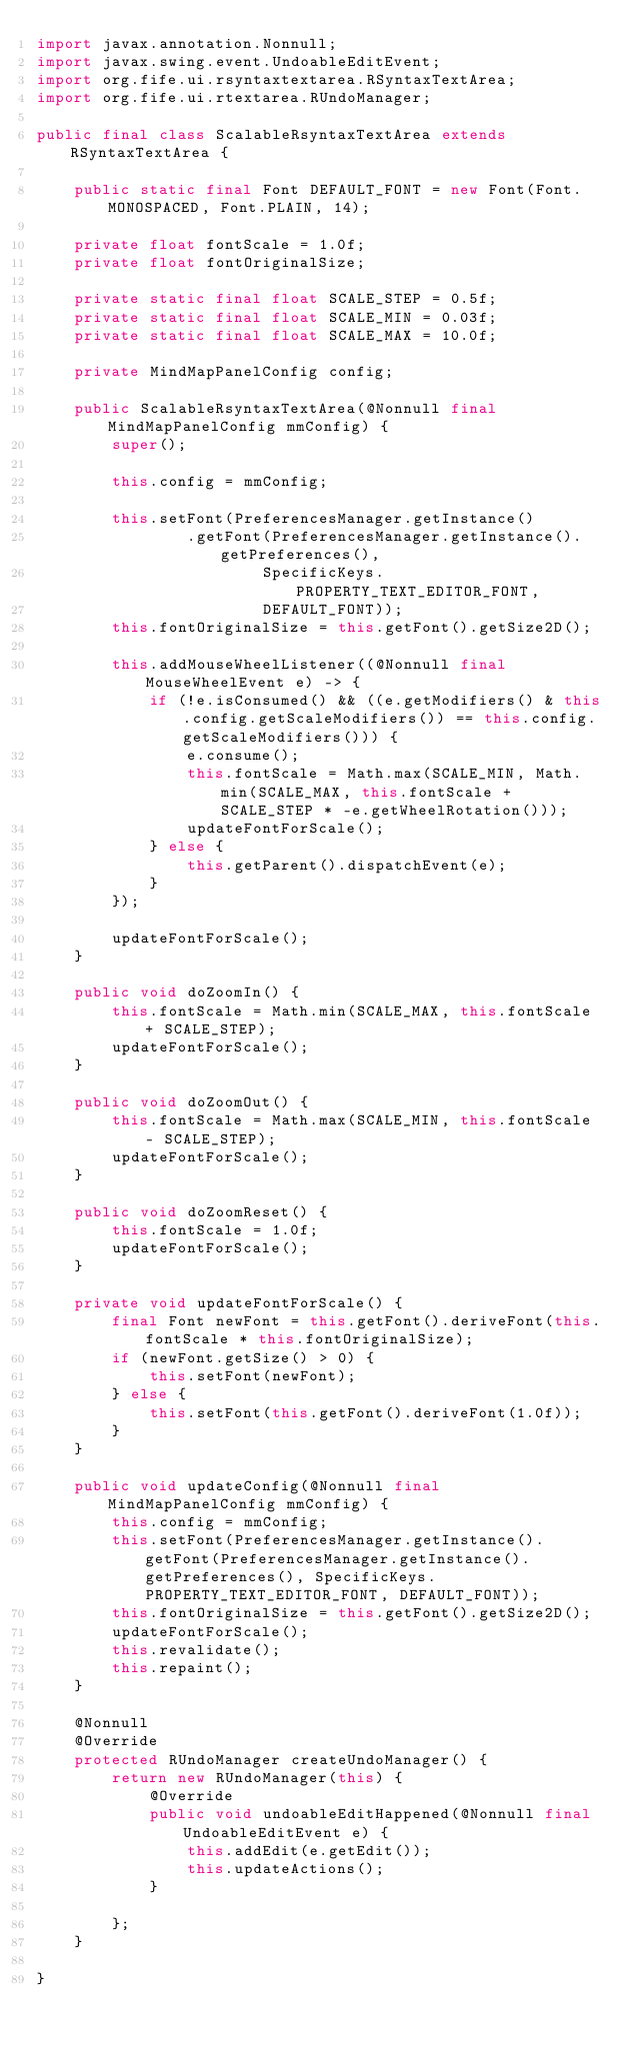Convert code to text. <code><loc_0><loc_0><loc_500><loc_500><_Java_>import javax.annotation.Nonnull;
import javax.swing.event.UndoableEditEvent;
import org.fife.ui.rsyntaxtextarea.RSyntaxTextArea;
import org.fife.ui.rtextarea.RUndoManager;

public final class ScalableRsyntaxTextArea extends RSyntaxTextArea {

    public static final Font DEFAULT_FONT = new Font(Font.MONOSPACED, Font.PLAIN, 14);

    private float fontScale = 1.0f;
    private float fontOriginalSize;

    private static final float SCALE_STEP = 0.5f;
    private static final float SCALE_MIN = 0.03f;
    private static final float SCALE_MAX = 10.0f;

    private MindMapPanelConfig config;

    public ScalableRsyntaxTextArea(@Nonnull final MindMapPanelConfig mmConfig) {
        super();

        this.config = mmConfig;

        this.setFont(PreferencesManager.getInstance()
                .getFont(PreferencesManager.getInstance().getPreferences(),
                        SpecificKeys.PROPERTY_TEXT_EDITOR_FONT,
                        DEFAULT_FONT));
        this.fontOriginalSize = this.getFont().getSize2D();

        this.addMouseWheelListener((@Nonnull final MouseWheelEvent e) -> {
            if (!e.isConsumed() && ((e.getModifiers() & this.config.getScaleModifiers()) == this.config.getScaleModifiers())) {
                e.consume();
                this.fontScale = Math.max(SCALE_MIN, Math.min(SCALE_MAX, this.fontScale + SCALE_STEP * -e.getWheelRotation()));
                updateFontForScale();
            } else {
                this.getParent().dispatchEvent(e);
            }
        });

        updateFontForScale();
    }

    public void doZoomIn() {
        this.fontScale = Math.min(SCALE_MAX, this.fontScale + SCALE_STEP);
        updateFontForScale();
    }

    public void doZoomOut() {
        this.fontScale = Math.max(SCALE_MIN, this.fontScale - SCALE_STEP);
        updateFontForScale();
    }

    public void doZoomReset() {
        this.fontScale = 1.0f;
        updateFontForScale();
    }

    private void updateFontForScale() {
        final Font newFont = this.getFont().deriveFont(this.fontScale * this.fontOriginalSize);
        if (newFont.getSize() > 0) {
            this.setFont(newFont);
        } else {
            this.setFont(this.getFont().deriveFont(1.0f));
        }
    }

    public void updateConfig(@Nonnull final MindMapPanelConfig mmConfig) {
        this.config = mmConfig;
        this.setFont(PreferencesManager.getInstance().getFont(PreferencesManager.getInstance().getPreferences(), SpecificKeys.PROPERTY_TEXT_EDITOR_FONT, DEFAULT_FONT));
        this.fontOriginalSize = this.getFont().getSize2D();
        updateFontForScale();
        this.revalidate();
        this.repaint();
    }

    @Nonnull
    @Override
    protected RUndoManager createUndoManager() {
        return new RUndoManager(this) {
            @Override
            public void undoableEditHappened(@Nonnull final UndoableEditEvent e) {
                this.addEdit(e.getEdit());
                this.updateActions();
            }

        };
    }

}
</code> 